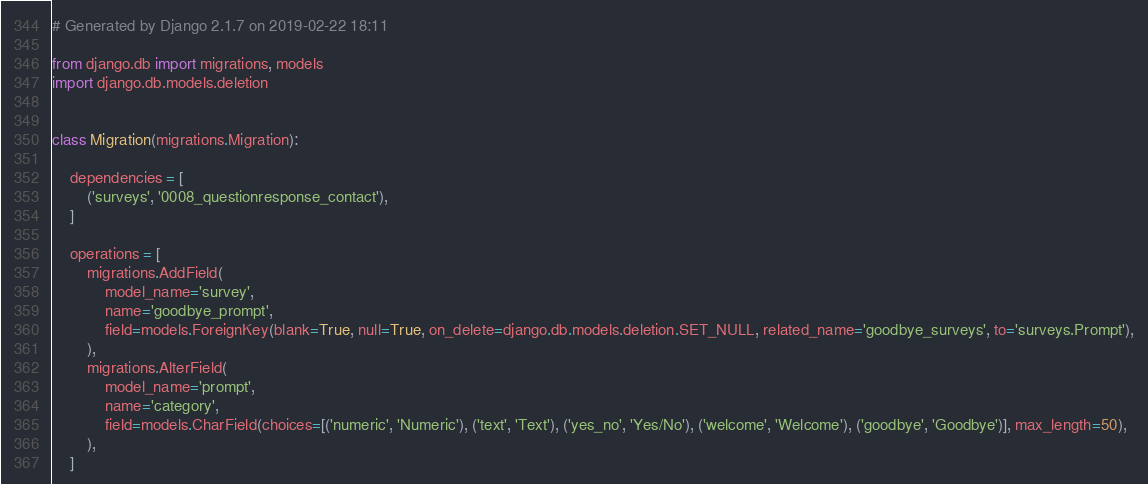<code> <loc_0><loc_0><loc_500><loc_500><_Python_># Generated by Django 2.1.7 on 2019-02-22 18:11

from django.db import migrations, models
import django.db.models.deletion


class Migration(migrations.Migration):

    dependencies = [
        ('surveys', '0008_questionresponse_contact'),
    ]

    operations = [
        migrations.AddField(
            model_name='survey',
            name='goodbye_prompt',
            field=models.ForeignKey(blank=True, null=True, on_delete=django.db.models.deletion.SET_NULL, related_name='goodbye_surveys', to='surveys.Prompt'),
        ),
        migrations.AlterField(
            model_name='prompt',
            name='category',
            field=models.CharField(choices=[('numeric', 'Numeric'), ('text', 'Text'), ('yes_no', 'Yes/No'), ('welcome', 'Welcome'), ('goodbye', 'Goodbye')], max_length=50),
        ),
    ]
</code> 